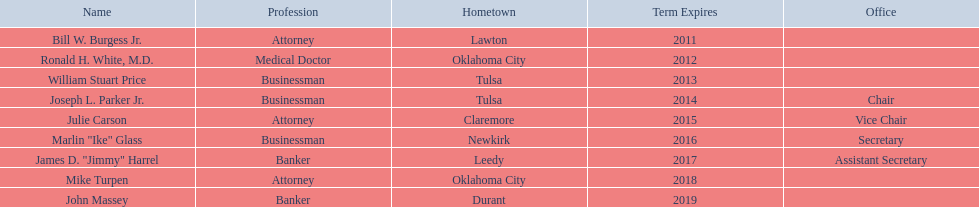What are all the names of oklahoma state regents for higher educations? Bill W. Burgess Jr., Ronald H. White, M.D., William Stuart Price, Joseph L. Parker Jr., Julie Carson, Marlin "Ike" Glass, James D. "Jimmy" Harrel, Mike Turpen, John Massey. Which ones are businessmen? William Stuart Price, Joseph L. Parker Jr., Marlin "Ike" Glass. Of those, who is from tulsa? William Stuart Price, Joseph L. Parker Jr. Whose term expires in 2014? Joseph L. Parker Jr. 